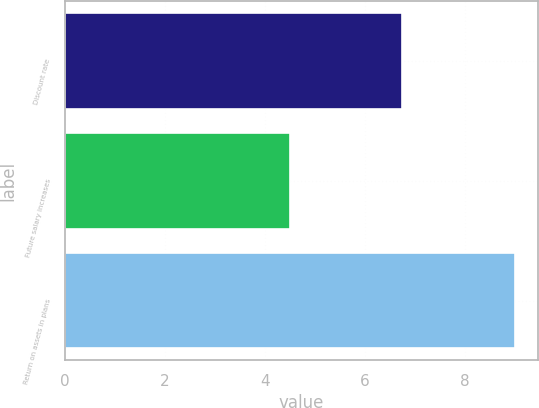Convert chart to OTSL. <chart><loc_0><loc_0><loc_500><loc_500><bar_chart><fcel>Discount rate<fcel>Future salary increases<fcel>Return on assets in plans<nl><fcel>6.75<fcel>4.5<fcel>9<nl></chart> 